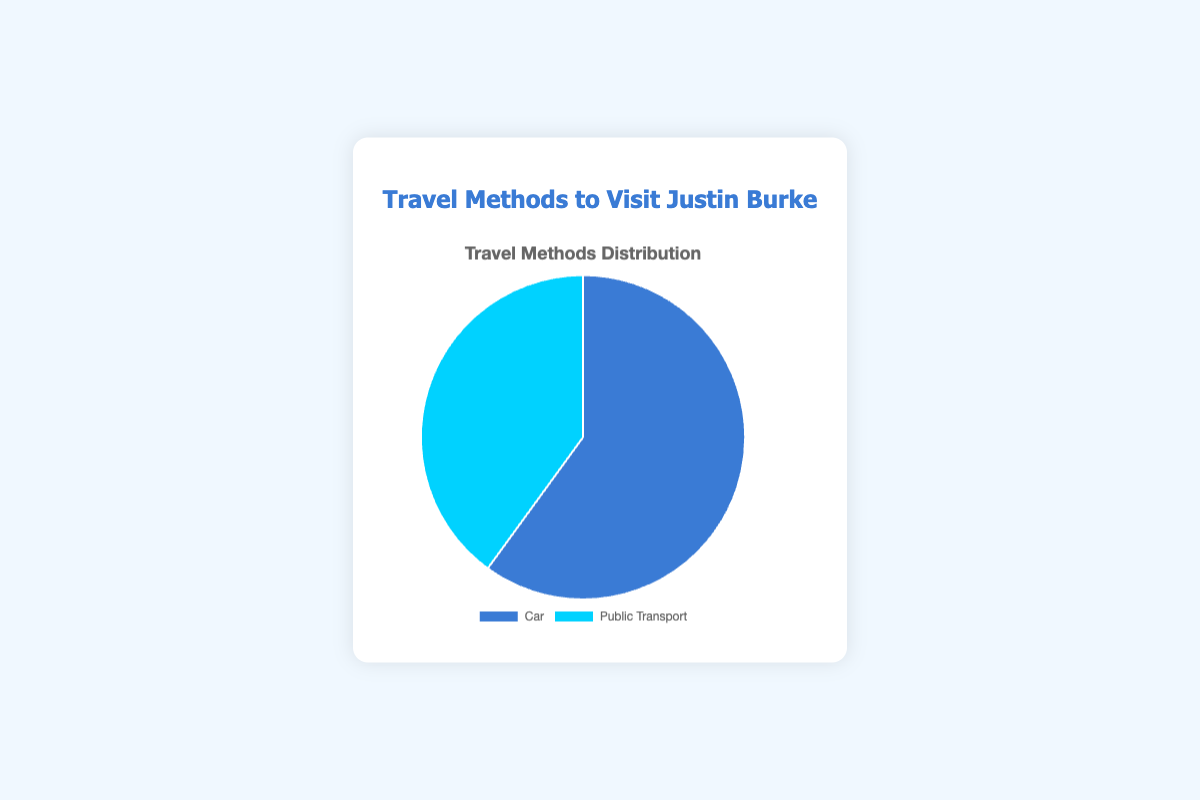What are the percentages for each travel method? To find the percentages, we sum the counts of both travel methods: 120 (Car) + 80 (Public Transport) = 200. Then, calculate each travel method's percentage: Car = (120 / 200) * 100 = 60%, Public Transport = (80 / 200) * 100 = 40%
Answer: Car: 60%, Public Transport: 40% Which travel method is more popular? We compare the counts of each travel method. Car has a count of 120, while Public Transport has a count of 80. Since 120 > 80, Car is more popular
Answer: Car How many more people use a car than public transport? We find the difference in counts between Car and Public Transport: 120 (Car) - 80 (Public Transport) = 40
Answer: 40 What is the ratio of Car users to Public Transport users? To find the ratio, we divide the counts of Car by Public Transport: 120 / 80 = 1.5. The ratio is 1.5:1
Answer: 1.5:1 Which section of the pie chart is larger? The Car section is larger since it has a higher count (120) compared to Public Transport (80)
Answer: Car What is the total number of people who use either travel method? The total number of people is the sum of Car and Public Transport users: 120 + 80 = 200
Answer: 200 If there were 50 more Public Transport users, would it be equal to the number of Car users? Adding 50 to the current Public Transport count: 80 + 50 = 130. Since 130 > 120, Public Transport would then have more users than Car
Answer: No Which section of the pie chart would you hover over to highlight Car users? Car users are represented by the section with a blue shade
Answer: Blue Is the percentage of Car users greater than half of the total number of users? Car users make up 60% of the total, which is greater than half (50%)
Answer: Yes If 20 people switch from using Car to Public Transport, what will be the new percentage distribution? New counts: Car = 120 - 20 = 100, Public Transport = 80 + 20 = 100. Total users = 200. New percentages: Car = (100/200) * 100 = 50%, Public Transport = (100/200) * 100 = 50%
Answer: Car: 50%, Public Transport: 50% 